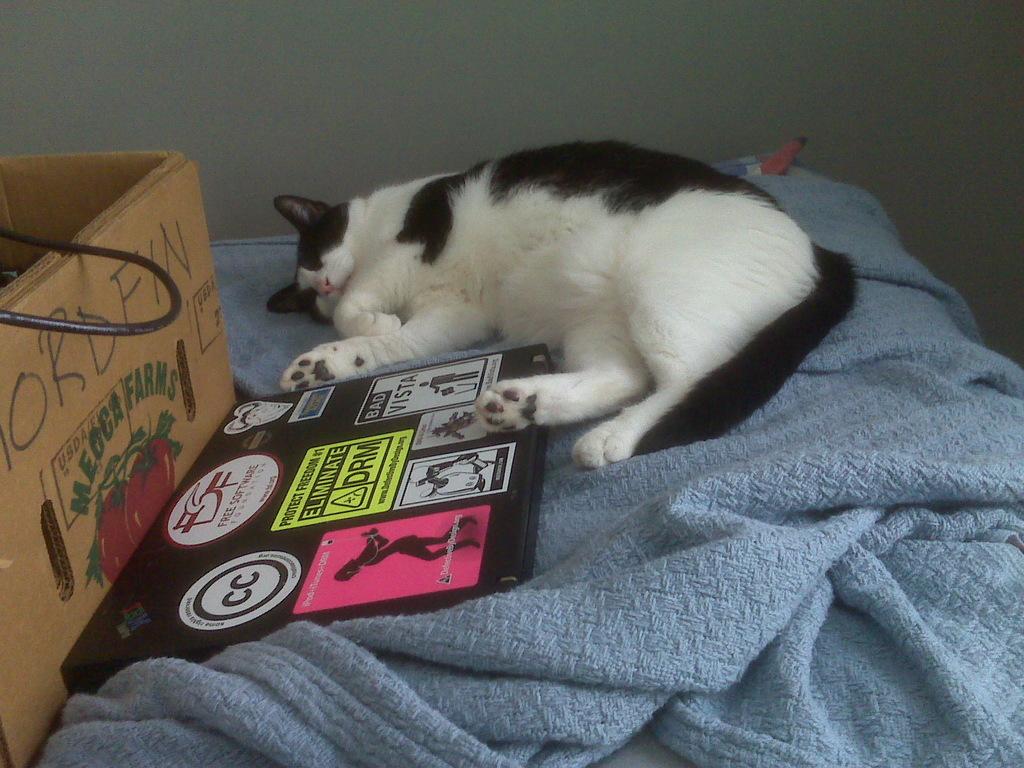What farm are these tomatoes from?
Offer a very short reply. Mecca farms. Protect freedom by eliminating what?
Make the answer very short. Drm. 